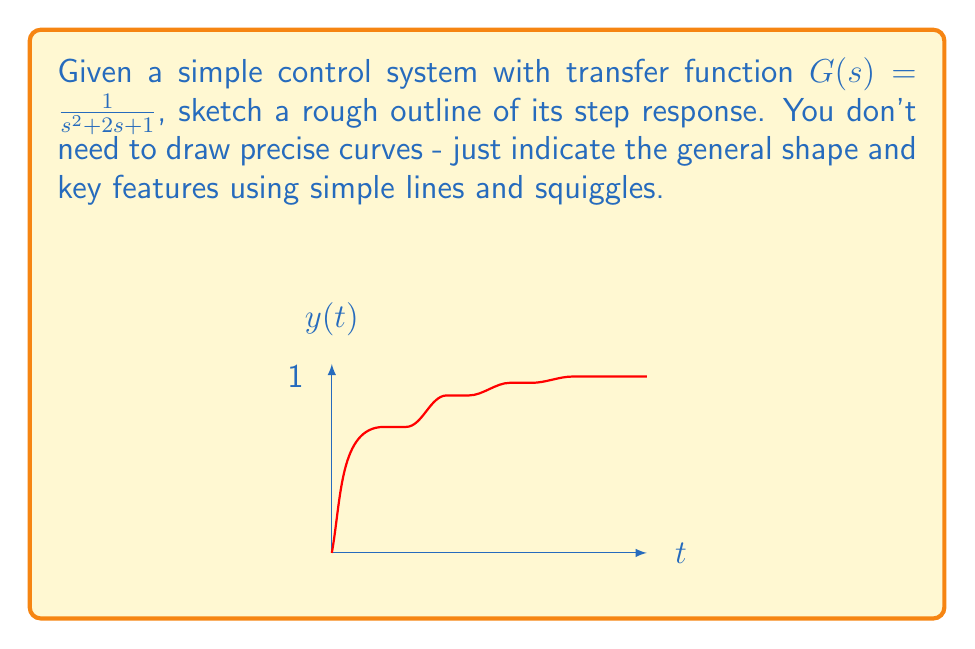Teach me how to tackle this problem. To analyze the step response of this control system:

1) The transfer function is given as $G(s) = \frac{1}{s^2 + 2s + 1}$

2) For a unit step input, $X(s) = \frac{1}{s}$

3) The output in Laplace domain is:
   $$Y(s) = G(s)X(s) = \frac{1}{s(s^2 + 2s + 1)}$$

4) Partial fraction decomposition gives:
   $$Y(s) = \frac{1}{s} - \frac{s+1}{s^2 + 2s + 1}$$

5) Taking the inverse Laplace transform:
   $$y(t) = 1 - e^{-t}(\cos t + \sin t)$$

6) Key features of this response:
   - It starts at 0 when $t=0$
   - It rises quickly at first, then more slowly
   - It approaches 1 as $t$ approaches infinity
   - There's no overshoot
   - It's a critically damped response

7) The rough sketch should show:
   - A curve starting at (0,0)
   - Rising quickly at first, then more gradually
   - Asymptotically approaching 1
   - No oscillations or overshoots

Remember, as a doodler who dislikes detailed artwork, a simple, rough sketch is sufficient to capture these key features.
Answer: Critically damped response approaching 1 with no overshoot 